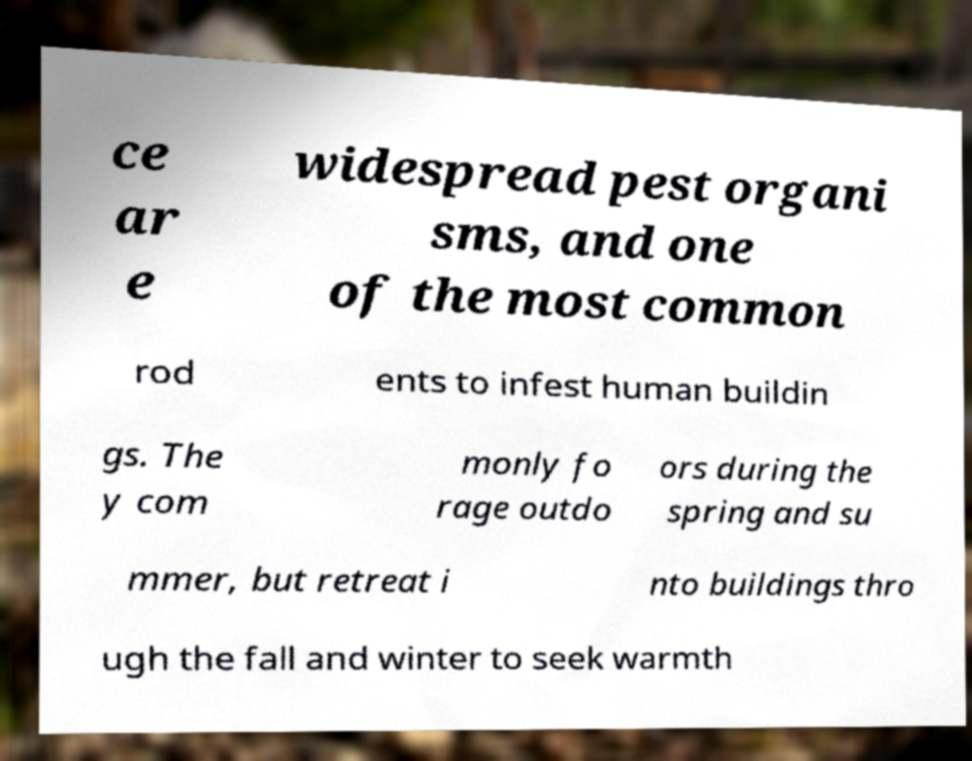What messages or text are displayed in this image? I need them in a readable, typed format. ce ar e widespread pest organi sms, and one of the most common rod ents to infest human buildin gs. The y com monly fo rage outdo ors during the spring and su mmer, but retreat i nto buildings thro ugh the fall and winter to seek warmth 